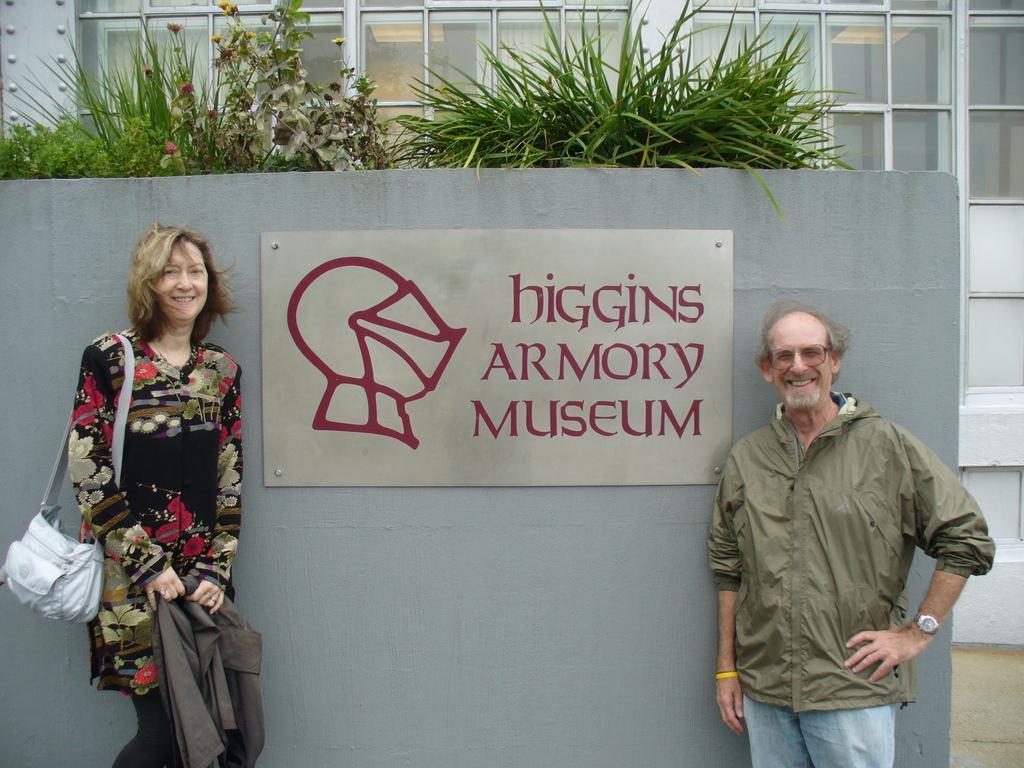Could you give a brief overview of what you see in this image? This picture is clicked outside. On the right there is a man wearing a jacket, smiling and standing on the ground. On the left we can see a woman wearing sling bag, smiling, holding an object and standing on the floor and we can see the poster containing the text and the depiction of some object and the poster is attached to a wall like object. At the top we can see the plants and the grass. In the background we can see the building. 